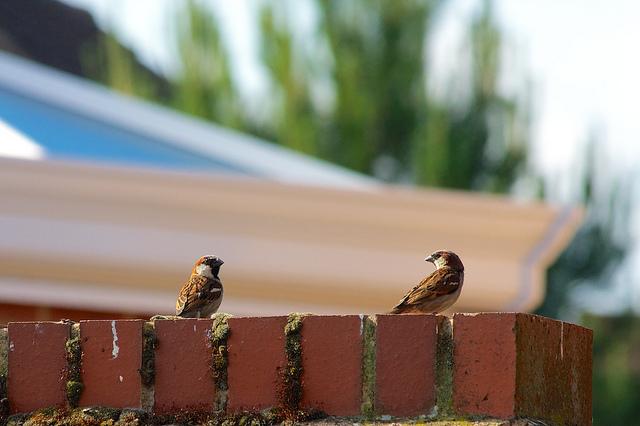What color is the brick?
Give a very brief answer. Red. How many birds are in the photo?
Quick response, please. 2. What type of bird are these?
Quick response, please. Sparrows. How many birds are on the wall?
Concise answer only. 2. Will the birds be flying soon?
Keep it brief. No. 